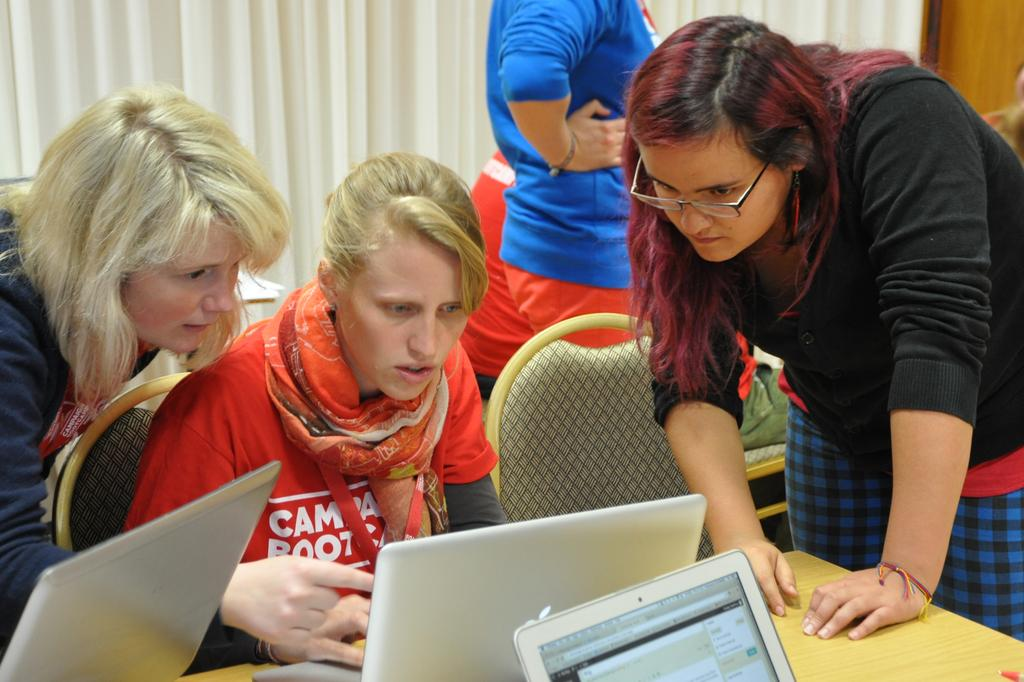What type of furniture is in the image? There is a table and chairs in the image. What is on the table in the image? Laptops are present on the table. What are the people doing in the image? People are sitting on the chairs. What can be seen at the top of the image? There is a curtain at the top of the image. What color is the curtain? The curtain is white in color. How does the dirt affect the grade of the laptops in the image? There is no dirt present in the image, so it cannot affect the grade of the laptops. 